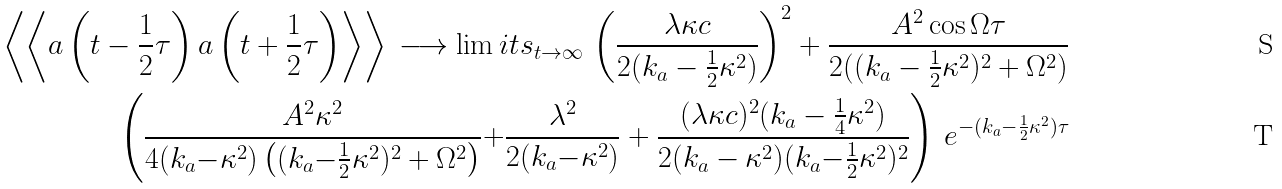<formula> <loc_0><loc_0><loc_500><loc_500>\left \langle \left \langle a \left ( t - { \frac { 1 } { 2 } } \tau \right ) a \left ( t + { \frac { 1 } { 2 } } \tau \right ) \right \rangle \right \rangle \, \longrightarrow \lim i t s _ { t \to \infty } \, \left ( \frac { \lambda \kappa c } { 2 ( k _ { a } - \frac { 1 } { 2 } \kappa ^ { 2 } ) } \right ) ^ { 2 } + \frac { A ^ { 2 } \cos \Omega \tau } { 2 ( ( k _ { a } - \frac { 1 } { 2 } \kappa ^ { 2 } ) ^ { 2 } + \Omega ^ { 2 } ) } \\ \left ( \frac { A ^ { 2 } \kappa ^ { 2 } } { 4 ( k _ { a } { - } \kappa ^ { 2 } ) \left ( ( k _ { a } { - } \frac { 1 } { 2 } \kappa ^ { 2 } ) ^ { 2 } + \Omega ^ { 2 } \right ) } { + } \frac { \lambda ^ { 2 } } { 2 ( k _ { a } { - } \kappa ^ { 2 } ) } + \frac { ( \lambda \kappa c ) ^ { 2 } ( k _ { a } - \frac { 1 } { 4 } \kappa ^ { 2 } ) } { 2 ( k _ { a } - \kappa ^ { 2 } ) ( k _ { a } { - } \frac { 1 } { 2 } \kappa ^ { 2 } ) ^ { 2 } } \right ) \, e ^ { - ( k _ { a } - \frac { 1 } { 2 } \kappa ^ { 2 } ) \tau }</formula> 